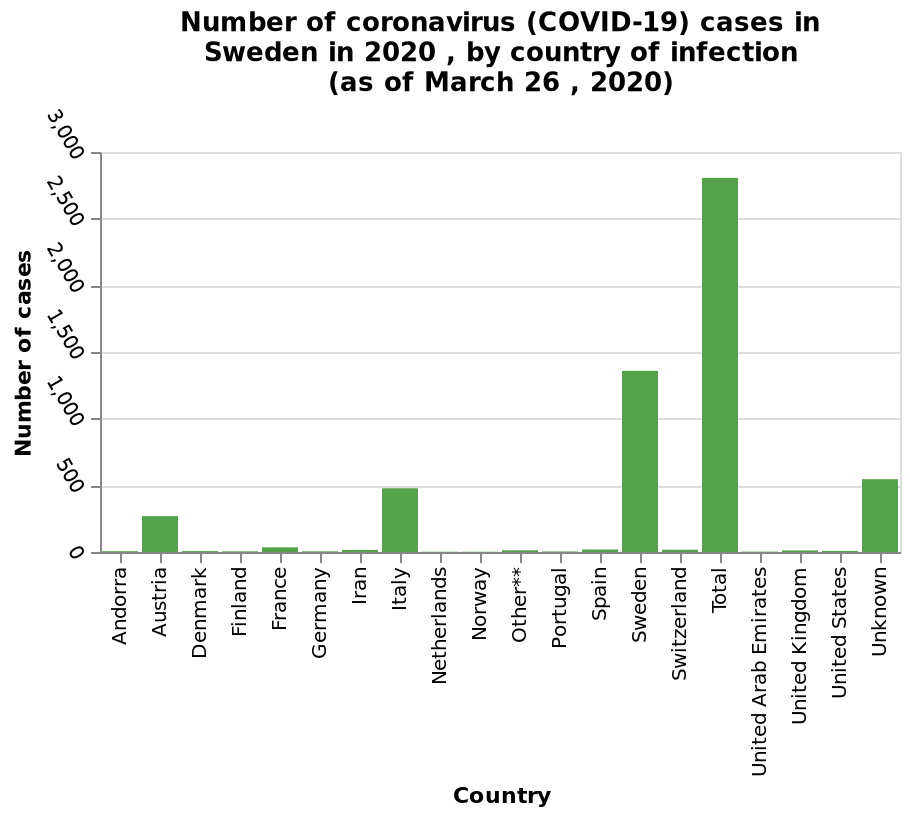<image>
What does the y-axis of the diagram represent?  The y-axis represents the number of cases of coronavirus (COVID-19) in Sweden in 2020. Which country has the lowest share of consumption?  Sweden. How many cases of coronavirus infection did Italy have in 2020 (by March)?  500 cases. 